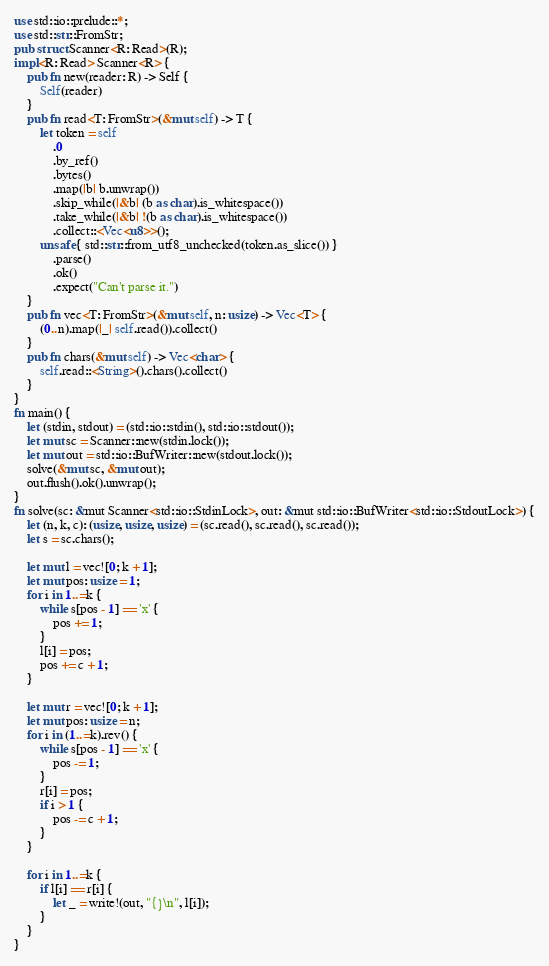<code> <loc_0><loc_0><loc_500><loc_500><_Rust_>use std::io::prelude::*;
use std::str::FromStr;
pub struct Scanner<R: Read>(R);
impl<R: Read> Scanner<R> {
    pub fn new(reader: R) -> Self {
        Self(reader)
    }
    pub fn read<T: FromStr>(&mut self) -> T {
        let token = self
            .0
            .by_ref()
            .bytes()
            .map(|b| b.unwrap())
            .skip_while(|&b| (b as char).is_whitespace())
            .take_while(|&b| !(b as char).is_whitespace())
            .collect::<Vec<u8>>();
        unsafe { std::str::from_utf8_unchecked(token.as_slice()) }
            .parse()
            .ok()
            .expect("Can't parse it.")
    }
    pub fn vec<T: FromStr>(&mut self, n: usize) -> Vec<T> {
        (0..n).map(|_| self.read()).collect()
    }
    pub fn chars(&mut self) -> Vec<char> {
        self.read::<String>().chars().collect()
    }
}
fn main() {
    let (stdin, stdout) = (std::io::stdin(), std::io::stdout());
    let mut sc = Scanner::new(stdin.lock());
    let mut out = std::io::BufWriter::new(stdout.lock());
    solve(&mut sc, &mut out);
    out.flush().ok().unwrap();
}
fn solve(sc: &mut Scanner<std::io::StdinLock>, out: &mut std::io::BufWriter<std::io::StdoutLock>) {
    let (n, k, c): (usize, usize, usize) = (sc.read(), sc.read(), sc.read());
    let s = sc.chars();

    let mut l = vec![0; k + 1];
    let mut pos: usize = 1;
    for i in 1..=k {
        while s[pos - 1] == 'x' {
            pos += 1;
        }
        l[i] = pos;
        pos += c + 1;
    }

    let mut r = vec![0; k + 1];
    let mut pos: usize = n;
    for i in (1..=k).rev() {
        while s[pos - 1] == 'x' {
            pos -= 1;
        }
        r[i] = pos;
        if i > 1 {
            pos -= c + 1;
        }
    }

    for i in 1..=k {
        if l[i] == r[i] {
            let _ = write!(out, "{}\n", l[i]);
        }
    }
}
</code> 